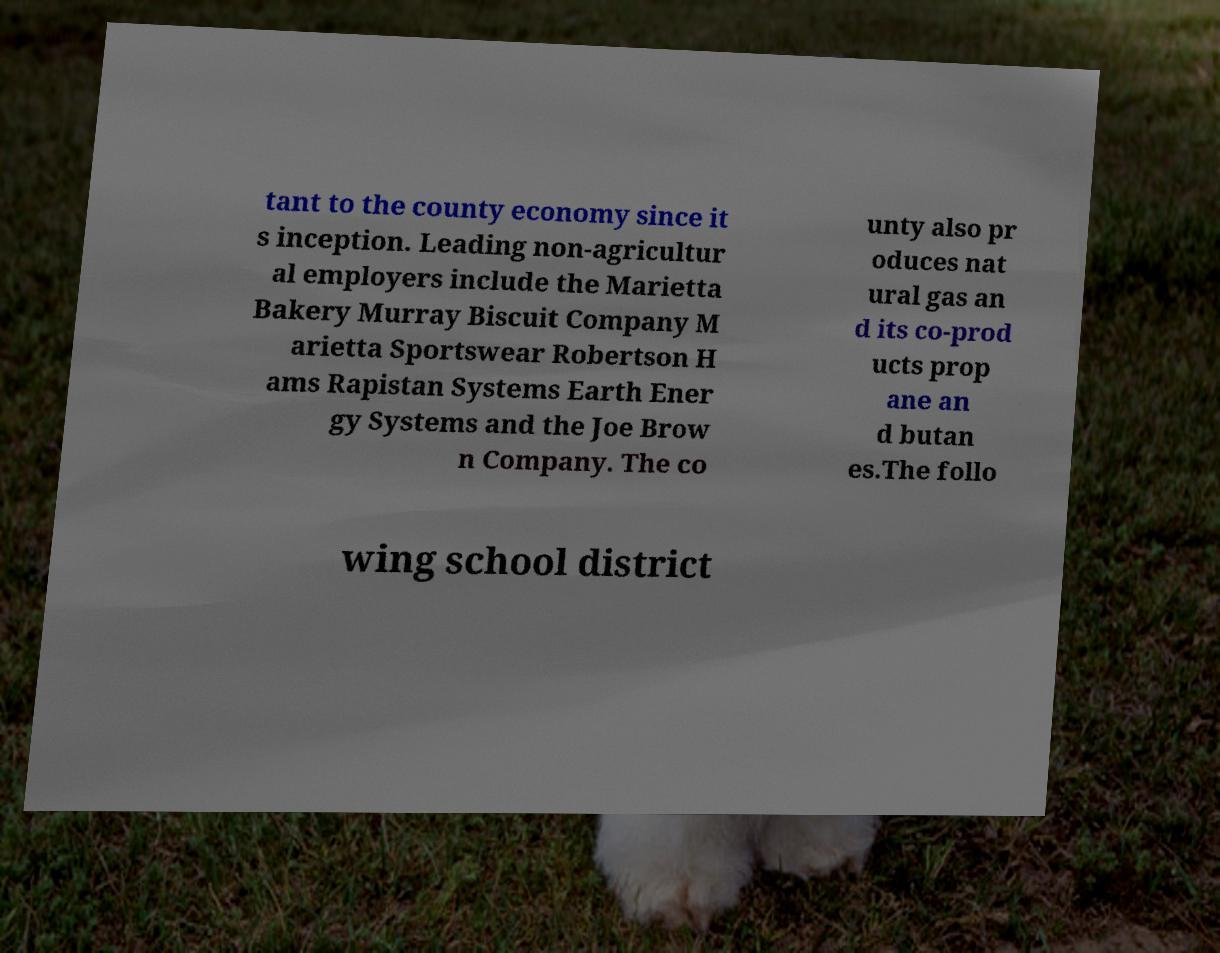Could you assist in decoding the text presented in this image and type it out clearly? tant to the county economy since it s inception. Leading non-agricultur al employers include the Marietta Bakery Murray Biscuit Company M arietta Sportswear Robertson H ams Rapistan Systems Earth Ener gy Systems and the Joe Brow n Company. The co unty also pr oduces nat ural gas an d its co-prod ucts prop ane an d butan es.The follo wing school district 